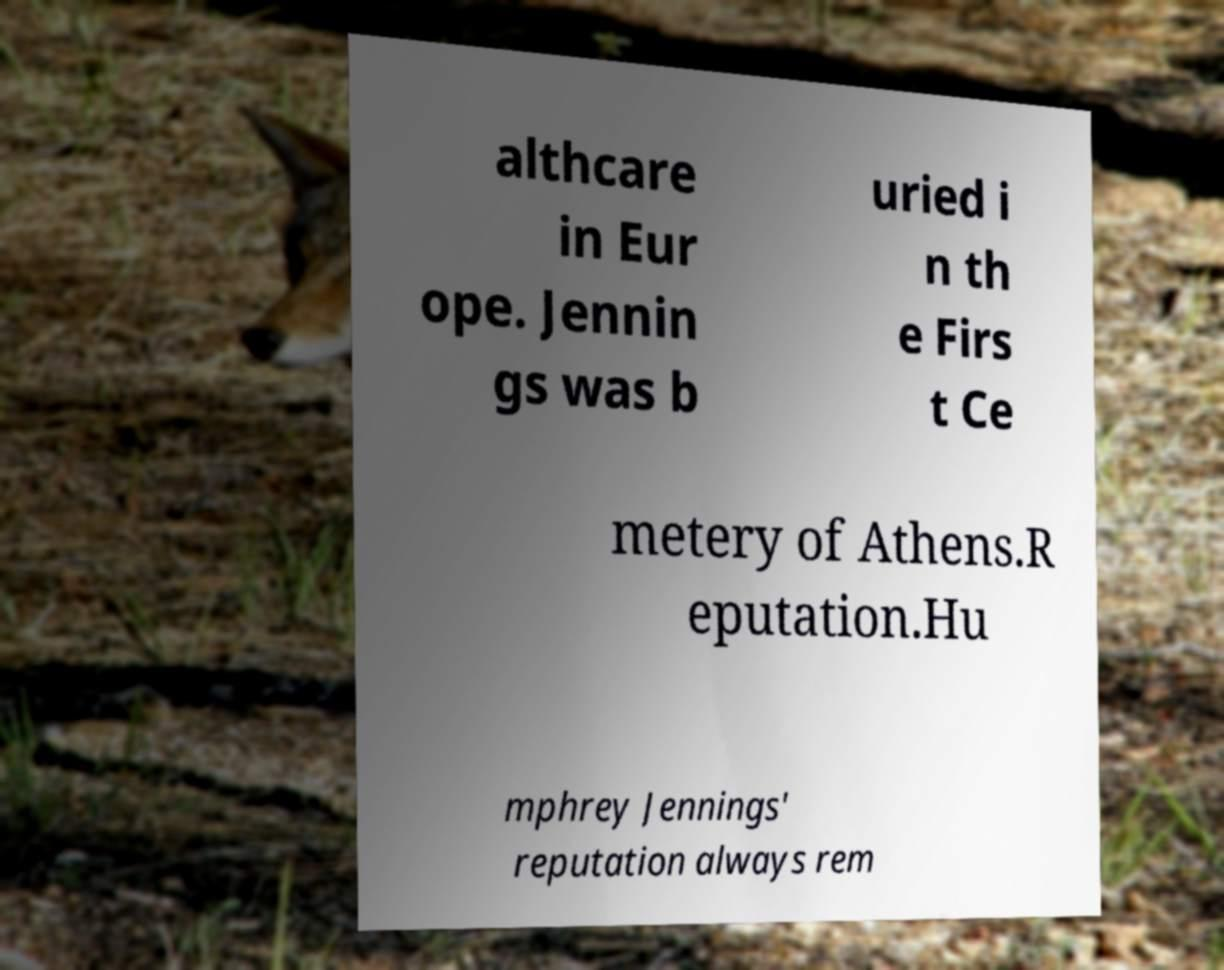Please identify and transcribe the text found in this image. althcare in Eur ope. Jennin gs was b uried i n th e Firs t Ce metery of Athens.R eputation.Hu mphrey Jennings' reputation always rem 